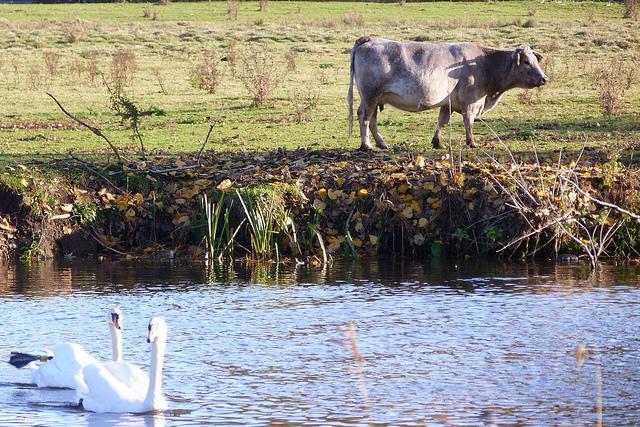What animal is standing by the bank?
Short answer required. Cow. Is this cow looking at the camera?
Give a very brief answer. No. Is this animal small enough to fit in a suitcase?
Be succinct. No. What is the animal doing?
Write a very short answer. Standing. Is the cow tagged?
Give a very brief answer. No. What color are the swans?
Write a very short answer. White. How many ducks are clearly seen?
Be succinct. 2. What color is the cow?
Short answer required. Gray. What is this animal?
Write a very short answer. Cow. How many swans are pictured?
Give a very brief answer. 2. 